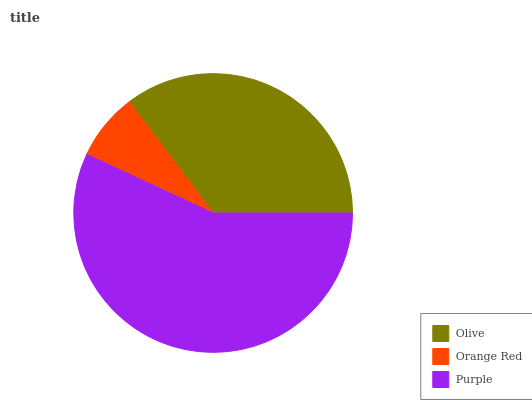Is Orange Red the minimum?
Answer yes or no. Yes. Is Purple the maximum?
Answer yes or no. Yes. Is Purple the minimum?
Answer yes or no. No. Is Orange Red the maximum?
Answer yes or no. No. Is Purple greater than Orange Red?
Answer yes or no. Yes. Is Orange Red less than Purple?
Answer yes or no. Yes. Is Orange Red greater than Purple?
Answer yes or no. No. Is Purple less than Orange Red?
Answer yes or no. No. Is Olive the high median?
Answer yes or no. Yes. Is Olive the low median?
Answer yes or no. Yes. Is Purple the high median?
Answer yes or no. No. Is Purple the low median?
Answer yes or no. No. 